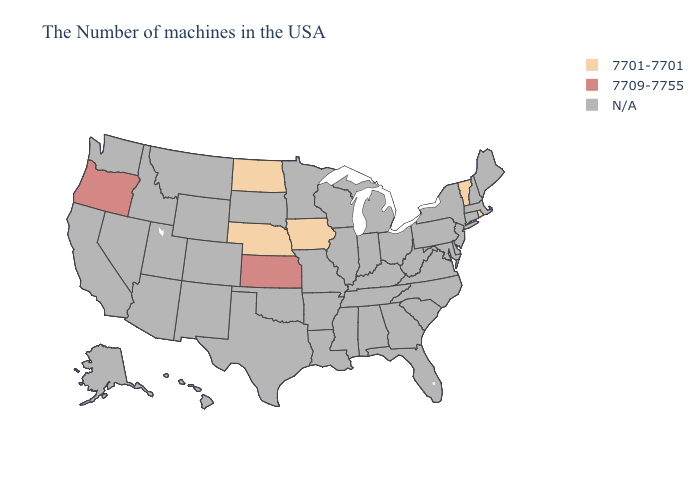What is the value of Ohio?
Write a very short answer. N/A. What is the lowest value in the Northeast?
Short answer required. 7701-7701. Which states have the lowest value in the Northeast?
Keep it brief. Rhode Island, Vermont. Which states have the lowest value in the MidWest?
Be succinct. Iowa, Nebraska, North Dakota. What is the lowest value in states that border Iowa?
Concise answer only. 7701-7701. Does Kansas have the highest value in the MidWest?
Give a very brief answer. Yes. Name the states that have a value in the range 7709-7755?
Quick response, please. Kansas, Oregon. Among the states that border Missouri , which have the highest value?
Concise answer only. Kansas. Does the first symbol in the legend represent the smallest category?
Quick response, please. Yes. 